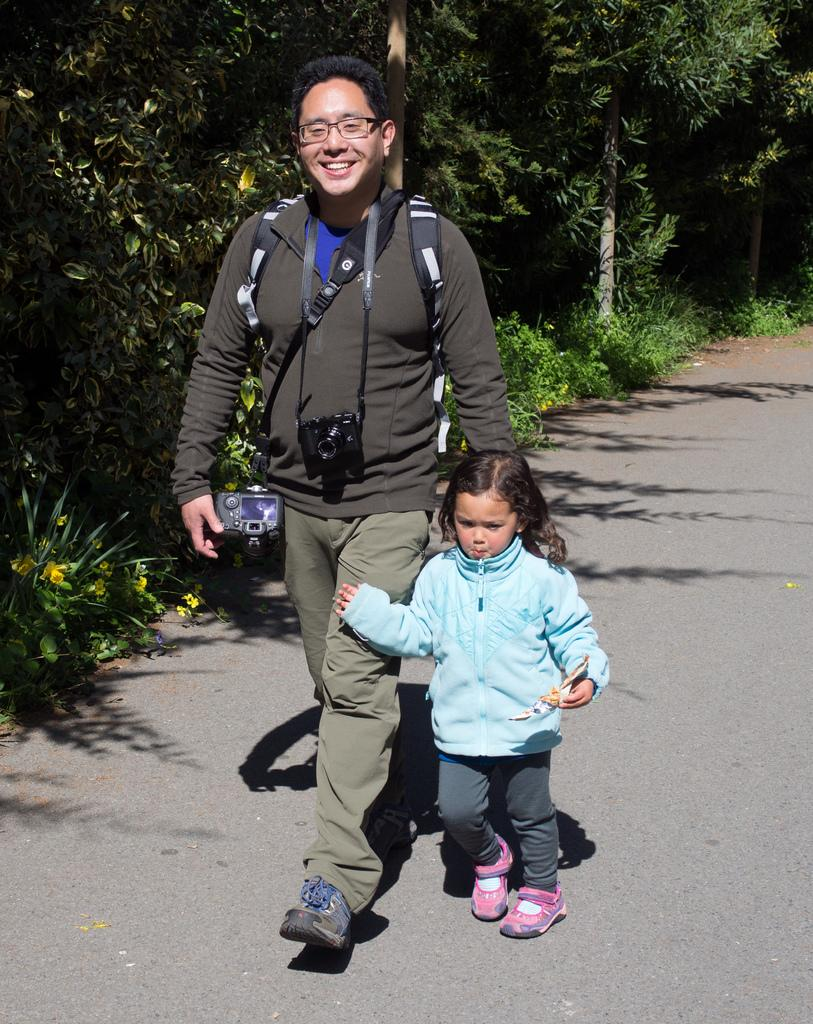Who is present in the image? There is a person and a child in the image. What are the person and child doing in the image? The person and child are walking on a road in the image. What type of vegetation can be seen in the image? There are trees, plants, and grass in the image. What is the weight of the person's heart in the image? There is no information about the person's heart or its weight in the image. 